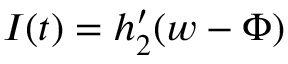<formula> <loc_0><loc_0><loc_500><loc_500>I ( t ) = h _ { 2 } ^ { \prime } ( w - \Phi )</formula> 